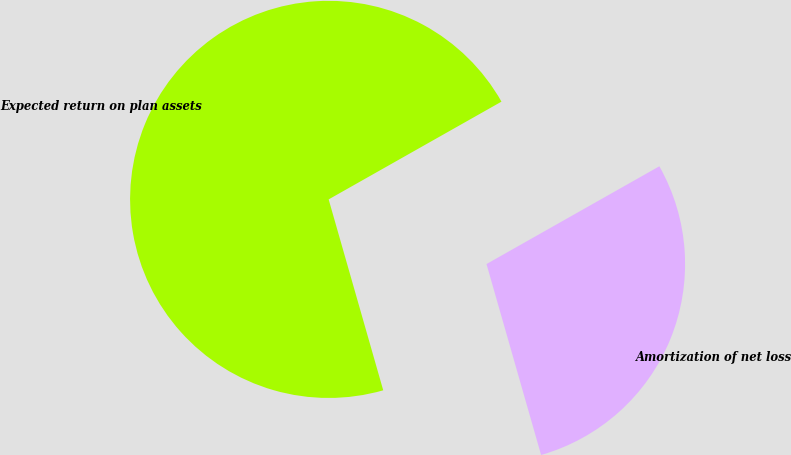<chart> <loc_0><loc_0><loc_500><loc_500><pie_chart><fcel>Expected return on plan assets<fcel>Amortization of net loss<nl><fcel>71.24%<fcel>28.76%<nl></chart> 